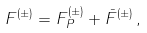<formula> <loc_0><loc_0><loc_500><loc_500>F ^ { ( \pm ) } = F ^ { ( \pm ) } _ { P } + \bar { F } ^ { ( \pm ) } \, ,</formula> 